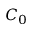<formula> <loc_0><loc_0><loc_500><loc_500>C _ { 0 }</formula> 